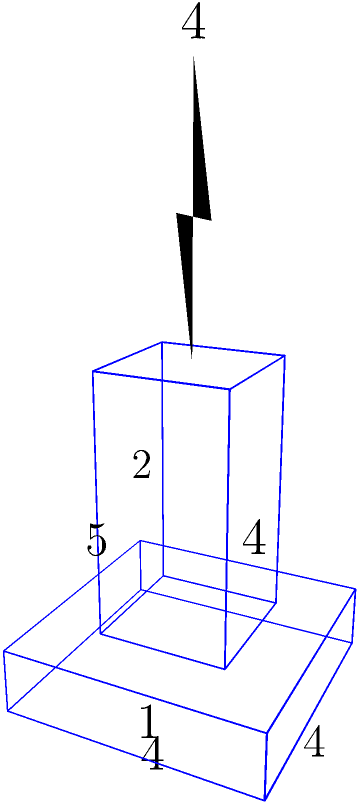As a domino artist, you've created a complex structure inspired by the Eiffel Tower for a social media post about Bastille Day. The structure consists of a rectangular base, a central tower, and a spire. The base measures 4x4x1 units, the central tower is 2x2x4 units, and the spire is a pyramid with a square base of 1x1 units and a height of 4 units. Calculate the total volume of this domino structure in cubic units. Let's break this down step-by-step:

1) Volume of the base:
   $$V_{base} = 4 \times 4 \times 1 = 16 \text{ cubic units}$$

2) Volume of the central tower:
   $$V_{tower} = 2 \times 2 \times 4 = 16 \text{ cubic units}$$

3) Volume of the spire (pyramid):
   The volume of a pyramid is given by the formula: $$V = \frac{1}{3} \times \text{base area} \times \text{height}$$
   $$V_{spire} = \frac{1}{3} \times 1 \times 1 \times 4 = \frac{4}{3} \text{ cubic units}$$

4) Total volume:
   $$V_{total} = V_{base} + V_{tower} + V_{spire}$$
   $$V_{total} = 16 + 16 + \frac{4}{3} = 32 + \frac{4}{3} = \frac{100}{3} \text{ cubic units}$$

Therefore, the total volume of the domino structure is $\frac{100}{3}$ cubic units.
Answer: $\frac{100}{3}$ cubic units 